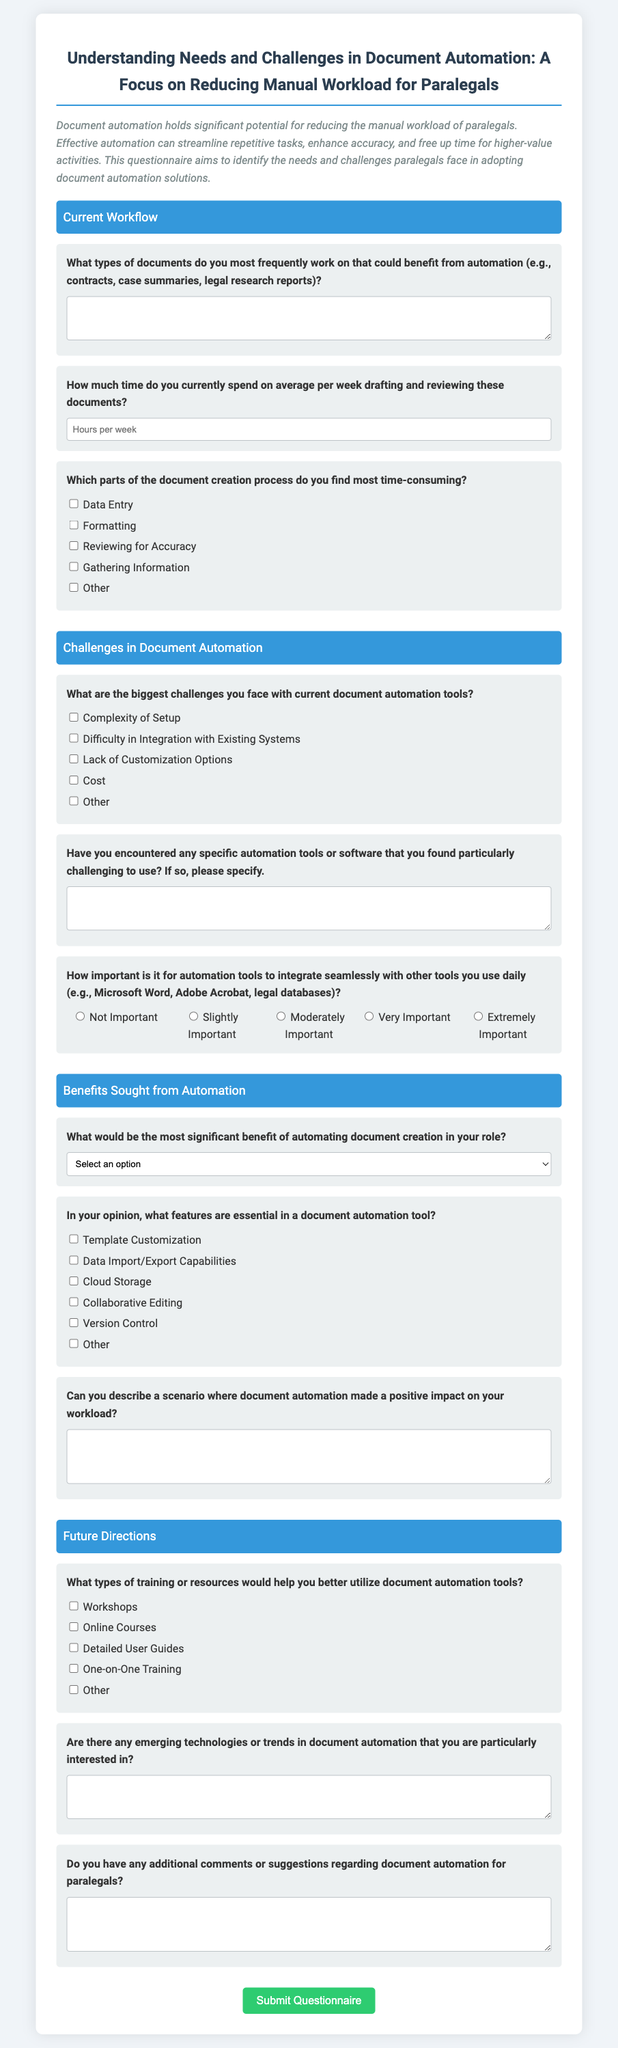What is the title of the questionnaire? The title is included at the top of the document and summarizes the focus on document automation for paralegals.
Answer: Understanding Needs and Challenges in Document Automation: A Focus on Reducing Manual Workload for Paralegals What is the primary goal of this questionnaire? The primary goal is stated in the introduction and revolves around identifying needs and challenges paralegals face regarding document automation solutions.
Answer: To identify the needs and challenges paralegals face in adopting document automation solutions How much time do paralegals currently spend on average per week drafting and reviewing documents? This question asks for a numerical response related to weekly workload in hours and is intended to gauge the current manual effort involved.
Answer: Hours per week What is one benefit sought from automation according to the questionnaire? The questionnaire lists several potential benefits in a dropdown menu, requiring the respondents to select one that resonates most with them.
Answer: Time Savings What types of training or resources are suggested to help better utilize document automation tools? The document lists several options that paralegals can select to indicate the type of training or resources they deem helpful.
Answer: Workshops What is one of the biggest challenges faced with current document automation tools? The questionnaire provides a checklist of challenges to identify which one respondents find most relevant to their experience.
Answer: Complexity of Setup What kind of feature is essential in a document automation tool according to the questionnaire? This question requires respondents to identify important features by selecting checkboxes, thus reflecting their practical needs.
Answer: Template Customization What section follows the challenges in document automation? The structure of the document has a clear order, with sections laid out sequentially for ease of understanding.
Answer: Benefits Sought from Automation What type of comments are solicited at the end of the questionnaire? The last question invites open-ended feedback, encouraging paralegals to share any additional insights or suggestions they may have.
Answer: Additional comments or suggestions regarding document automation for paralegals 